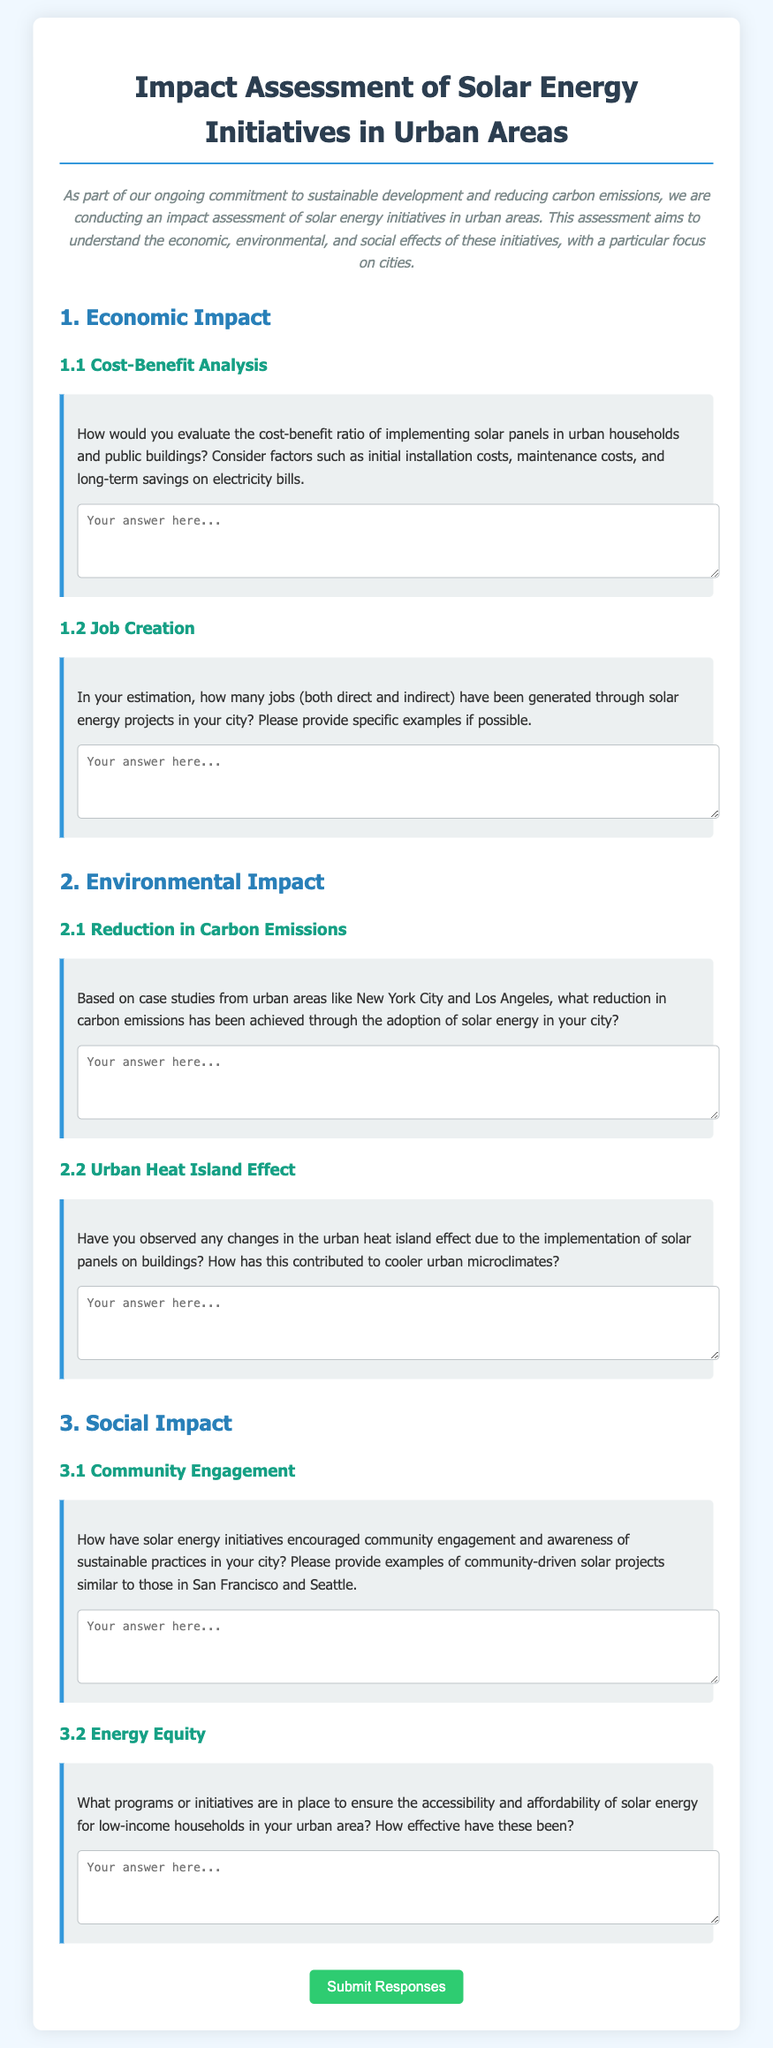What is the title of the document? The title is mentioned at the top of the document, which is "Impact Assessment of Solar Energy Initiatives in Urban Areas."
Answer: Impact Assessment of Solar Energy Initiatives in Urban Areas What section discusses job creation? The section related to job creation is identified in the document under "Economic Impact" with the heading "1.2 Job Creation."
Answer: 1.2 Job Creation What is the color of the submit button? The color of the submit button is described as green in the document.
Answer: green What is the introductory statement's tone? The introductory statement indicates a commitment to sustainability and is described as "As part of our ongoing commitment to sustainable development..."
Answer: commitment to sustainable development Based on the document, which urban areas are specifically mentioned in relation to carbon emissions reduction? The document mentions "New York City and Los Angeles" in regard to carbon emissions reduction.
Answer: New York City and Los Angeles What type of energy equity initiatives are aimed at low-income households? The document asks about "programs or initiatives" in relation to energy equity for low-income households.
Answer: programs or initiatives How many questions are in the "Social Impact" section? There are two questions in the "Social Impact" section of the questionnaire.
Answer: two questions What aspect of environmental impact does the section address related to urban heat? The document discusses changes in the "urban heat island effect" due to solar panels.
Answer: urban heat island effect How should one provide answers in the questionnaire? Answers are to be provided in the textarea fields designated for each question.
Answer: textarea fields 